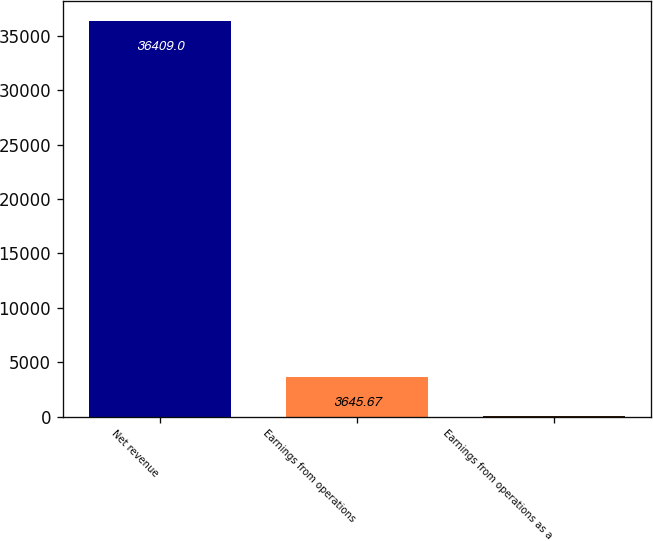<chart> <loc_0><loc_0><loc_500><loc_500><bar_chart><fcel>Net revenue<fcel>Earnings from operations<fcel>Earnings from operations as a<nl><fcel>36409<fcel>3645.67<fcel>5.3<nl></chart> 